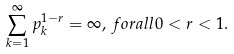<formula> <loc_0><loc_0><loc_500><loc_500>\sum _ { k = 1 } ^ { \infty } p _ { k } ^ { 1 - r } = \infty , \, f o r a l l 0 < r < 1 .</formula> 